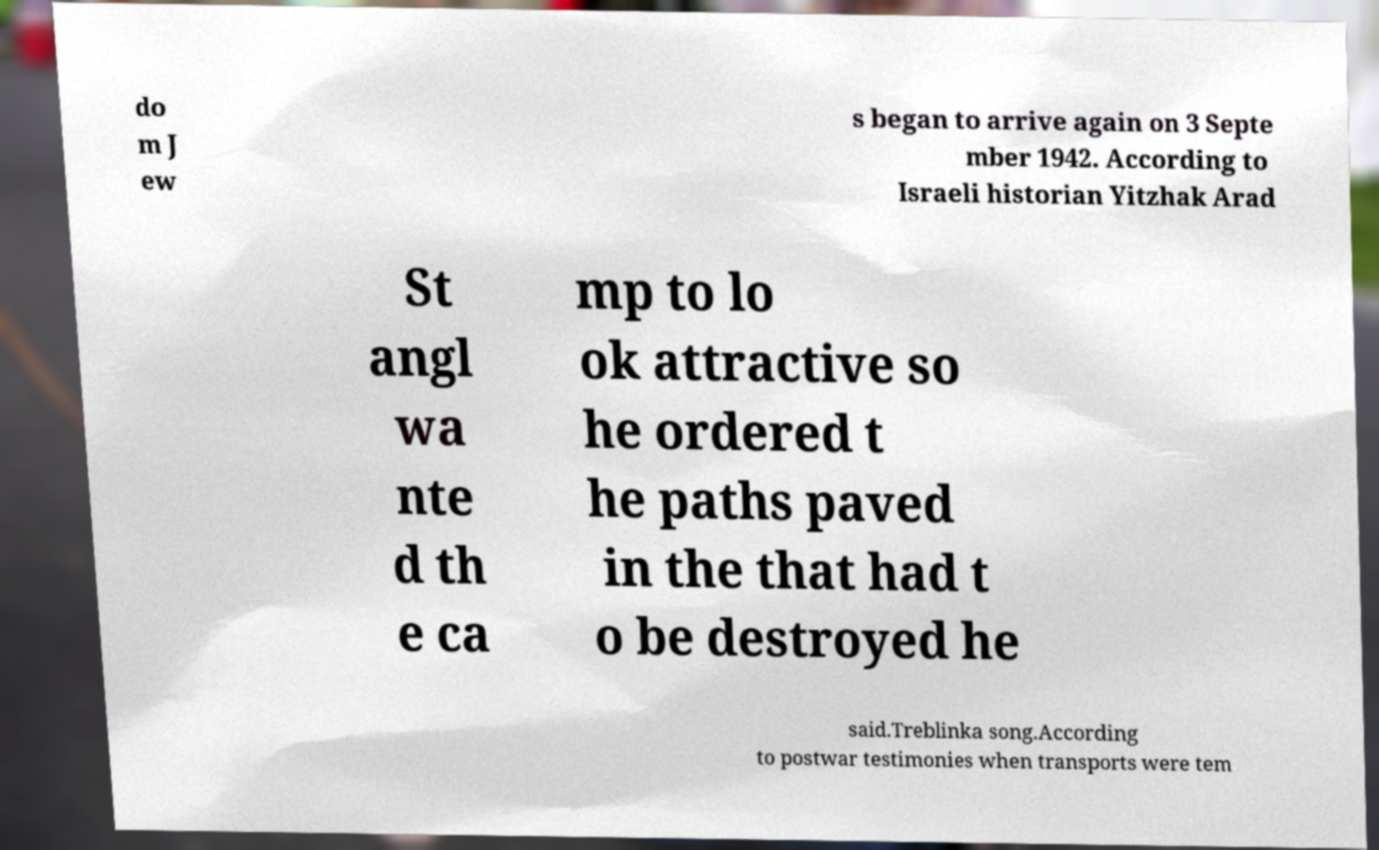Can you accurately transcribe the text from the provided image for me? do m J ew s began to arrive again on 3 Septe mber 1942. According to Israeli historian Yitzhak Arad St angl wa nte d th e ca mp to lo ok attractive so he ordered t he paths paved in the that had t o be destroyed he said.Treblinka song.According to postwar testimonies when transports were tem 